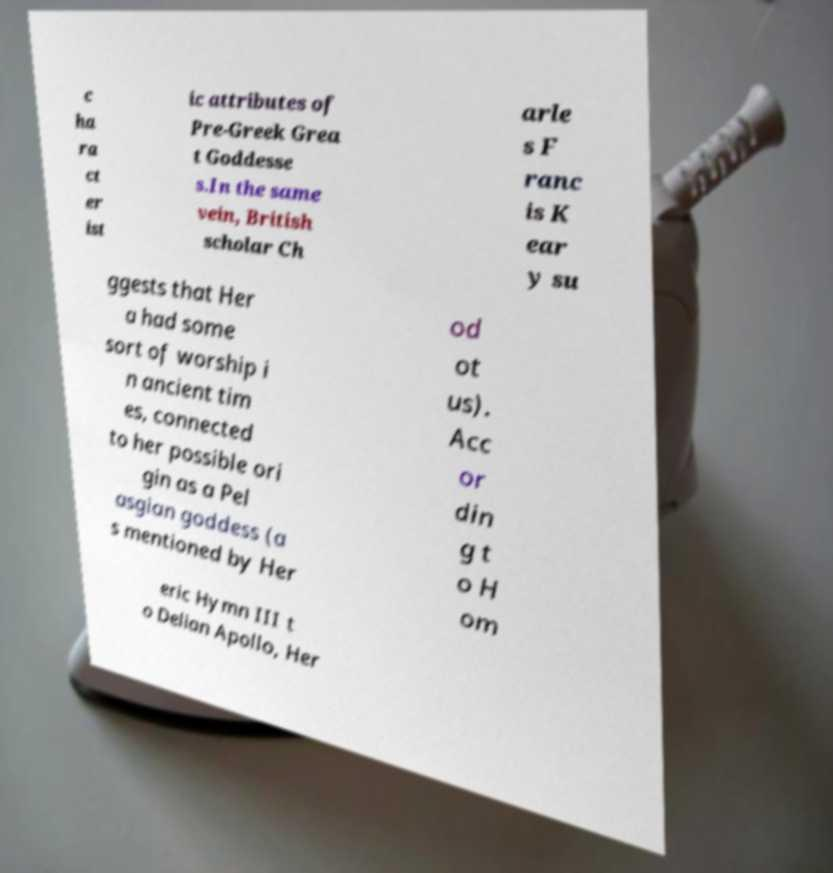Could you assist in decoding the text presented in this image and type it out clearly? c ha ra ct er ist ic attributes of Pre-Greek Grea t Goddesse s.In the same vein, British scholar Ch arle s F ranc is K ear y su ggests that Her a had some sort of worship i n ancient tim es, connected to her possible ori gin as a Pel asgian goddess (a s mentioned by Her od ot us). Acc or din g t o H om eric Hymn III t o Delian Apollo, Her 